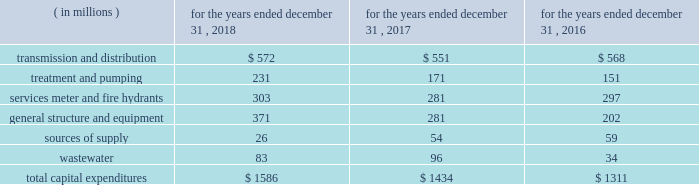The table provides a summary of our historical capital expenditures related to the upgrading of our infrastructure and systems: .
In 2018 , our capital expenditures increased $ 152 million , or 10.6% ( 10.6 % ) , primarily due to investment across the majority of our infrastructure categories .
In 2017 , our capital expenditures increased $ 123 million , or 9.4% ( 9.4 % ) , primarily due to investment in our general structure and equipment and wastewater categories .
We also grow our business primarily through acquisitions of water and wastewater systems , as well as other water-related services .
These acquisitions are complementary to our existing business and support continued geographical diversification and growth of our operations .
Generally , acquisitions are funded initially with short- term debt , and later refinanced with the proceeds from long-term debt .
The following is a summary of the acquisitions and dispositions affecting our cash flows from investing activities : 2022 the majority of cash paid for acquisitions pertained to the $ 365 million purchase of pivotal within our homeowner services group .
2022 paid $ 33 million for 15 water and wastewater systems , representing approximately 14000 customers .
2022 received $ 35 million for the sale of assets , including $ 27 million for the sale of the majority of the o&m contracts in our contract services group during the third quarter of 2018 .
2022 the majority of cash paid for acquisitions pertained to the $ 159 million purchase of the wastewater collection and treatment system assets of the municipal authority of the city of mckeesport , pennsylvania ( the 201cmckeesport system 201d ) , excluding a $ 5 million non-escrowed deposit made in 2016 .
2022 paid $ 18 million for 16 water and wastewater systems , excluding the mckeesport system and shorelands ( a stock-for-stock transaction ) , representing approximately 7000 customers .
2022 received $ 15 million for the sale of assets .
2022 paid $ 199 million for 15 water and wastewater systems , representing approximately 42000 customers .
2022 made a non-escrowed deposit of $ 5 million related to the mckeesport system acquisition .
2022 received $ 9 million for the sale of assets .
As previously noted , we expect to invest between $ 8.0 billion to $ 8.6 billion from 2019 to 2023 , with $ 7.3 billion of this range for infrastructure improvements in our regulated businesses .
In 2019 , we expect to .
For 2018 , wastewater was what percent of total capital expenditures? 
Computations: (83 / 1586)
Answer: 0.05233. 